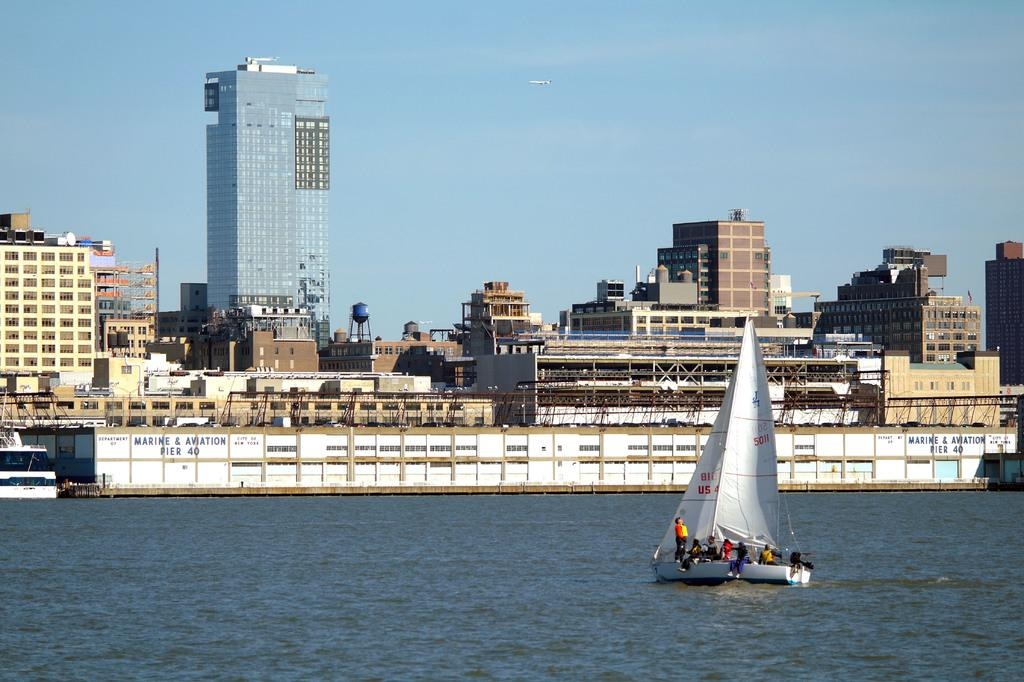What activity are the people in the image engaged in? The people in the image are sailing on a boat. Where is the boat located in the image? The boat is on the water. What can be seen in the background of the image? There are buildings visible in the image. What feature is present on the buildings? There are windows on the buildings. What is visible above the boat and buildings in the image? The sky is visible in the image. What type of prose is being recited during the meeting on the boat in the image? There is no indication of a meeting or any prose being recited in the image; it simply shows people sailing on a boat. 